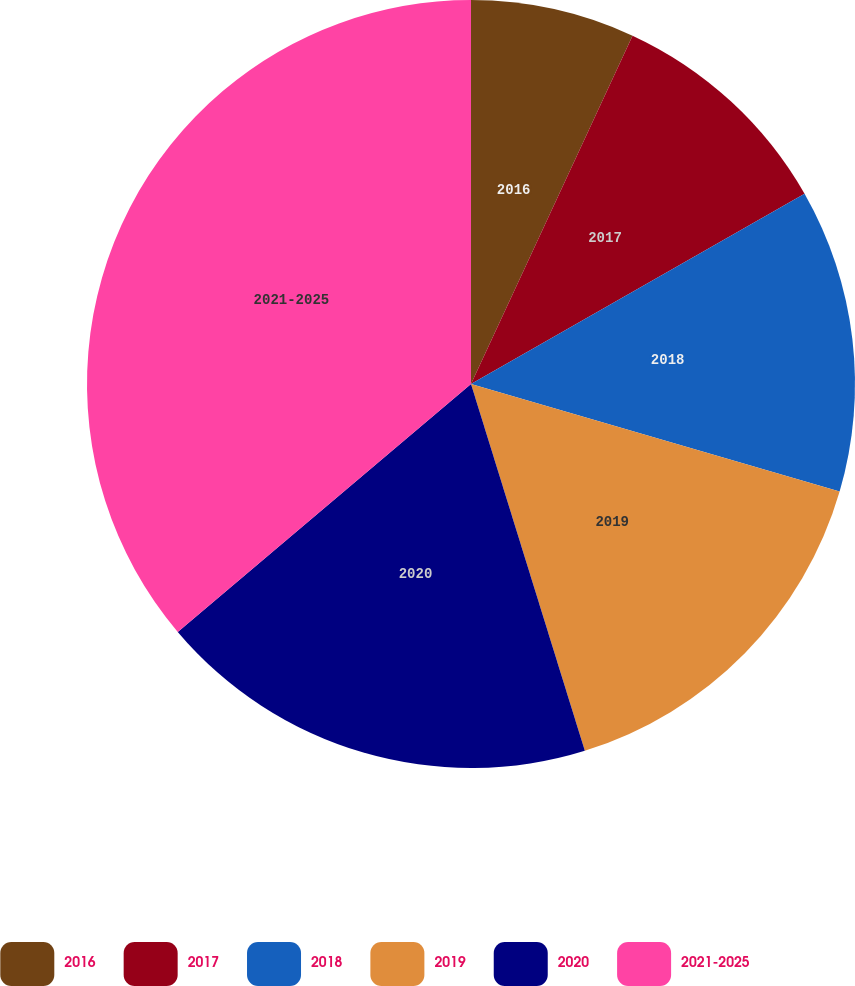Convert chart to OTSL. <chart><loc_0><loc_0><loc_500><loc_500><pie_chart><fcel>2016<fcel>2017<fcel>2018<fcel>2019<fcel>2020<fcel>2021-2025<nl><fcel>6.91%<fcel>9.84%<fcel>12.77%<fcel>15.69%<fcel>18.62%<fcel>36.17%<nl></chart> 